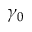Convert formula to latex. <formula><loc_0><loc_0><loc_500><loc_500>\gamma _ { 0 }</formula> 